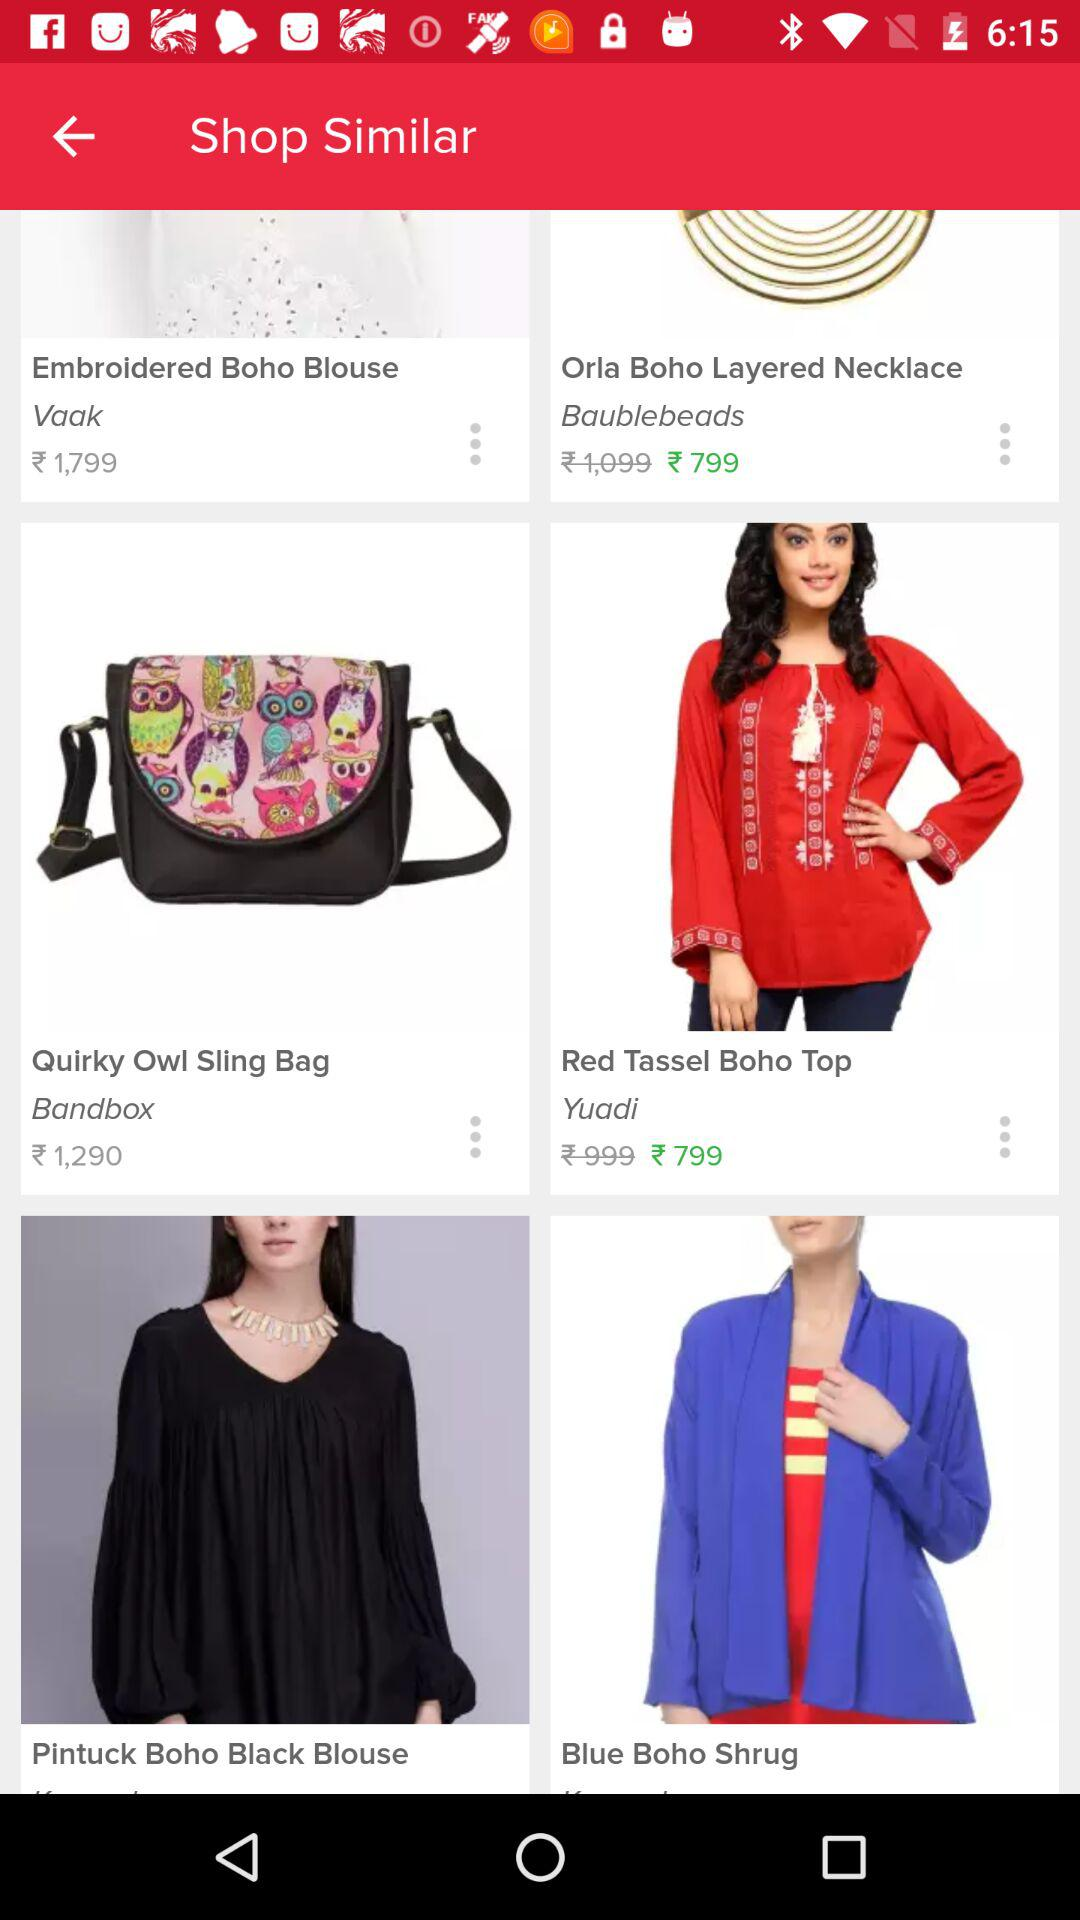What is the price for the "Red Tassel Boho Top"? The price is ₹799. 